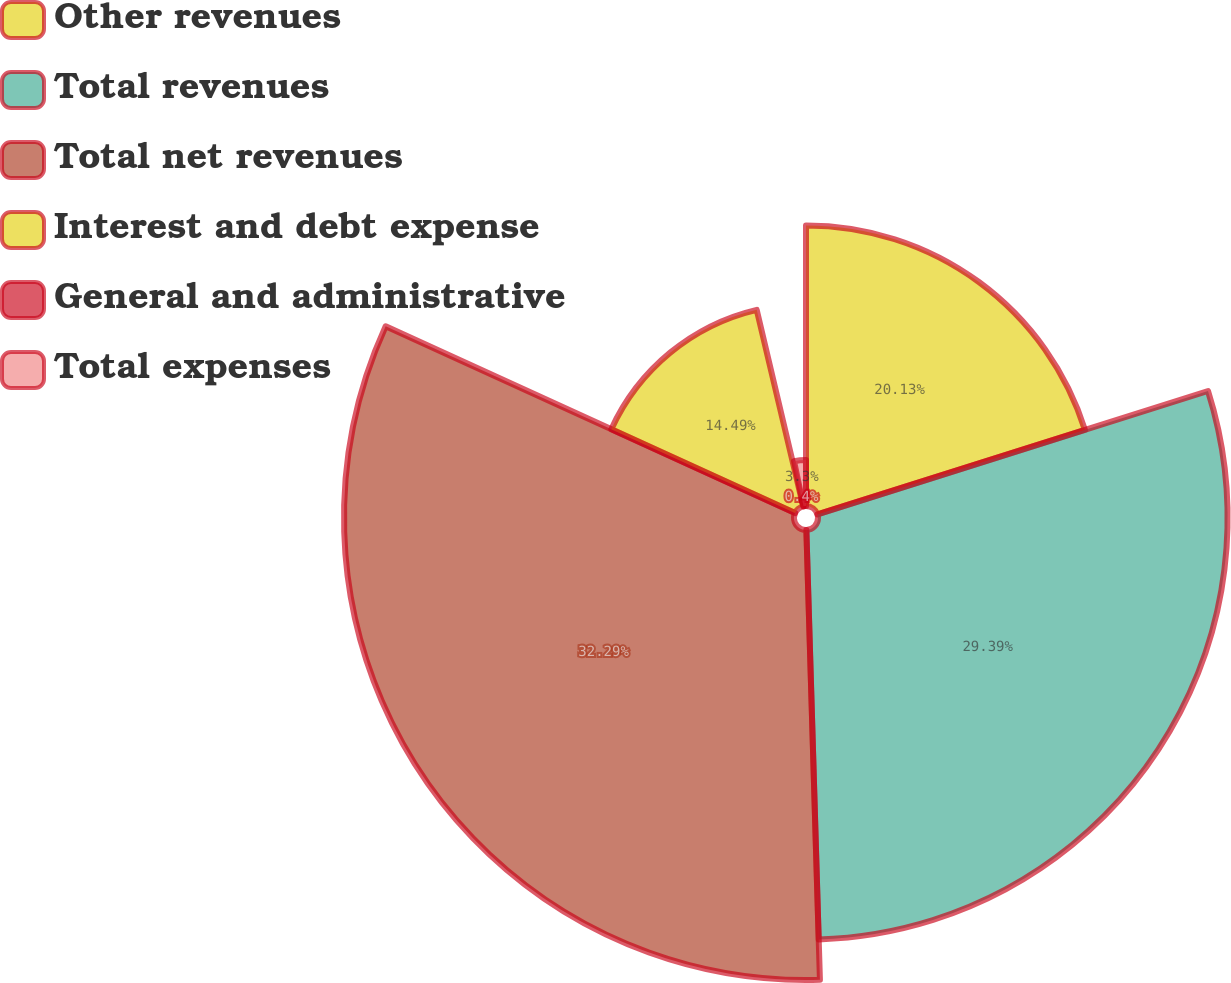Convert chart. <chart><loc_0><loc_0><loc_500><loc_500><pie_chart><fcel>Other revenues<fcel>Total revenues<fcel>Total net revenues<fcel>Interest and debt expense<fcel>General and administrative<fcel>Total expenses<nl><fcel>20.13%<fcel>29.39%<fcel>32.29%<fcel>14.49%<fcel>0.4%<fcel>3.3%<nl></chart> 